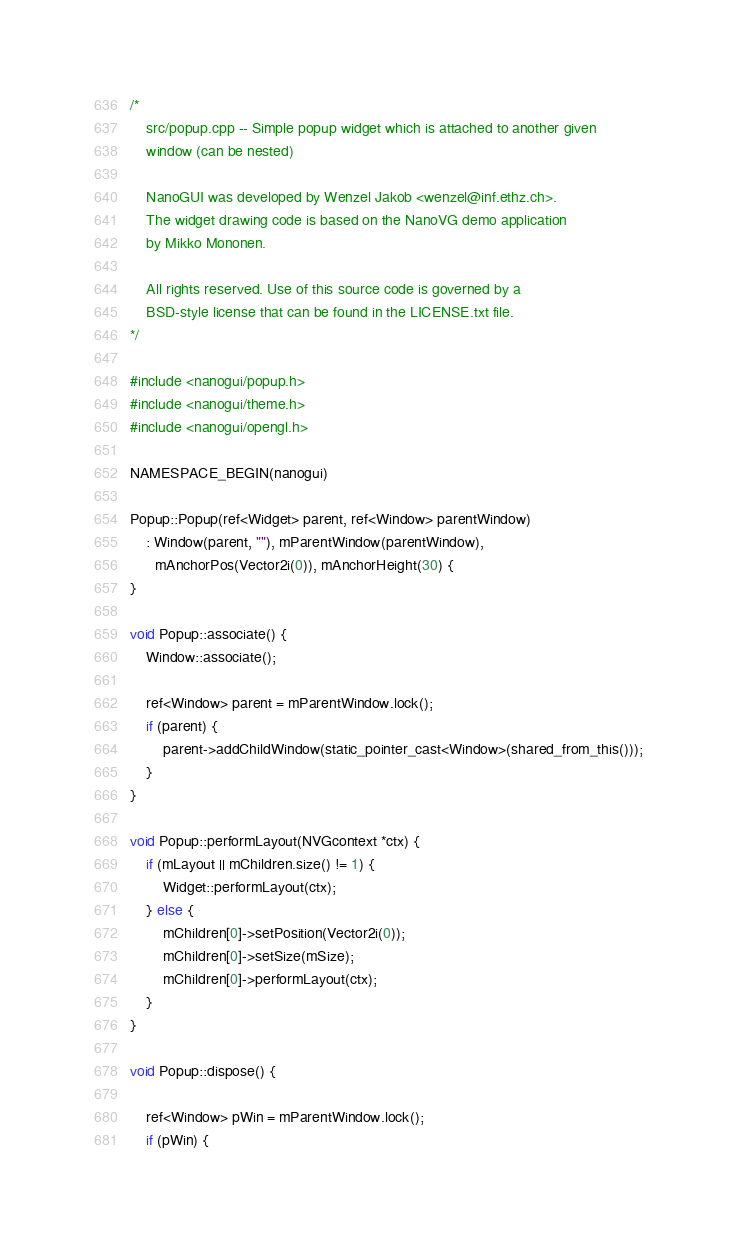Convert code to text. <code><loc_0><loc_0><loc_500><loc_500><_C++_>/*
    src/popup.cpp -- Simple popup widget which is attached to another given
    window (can be nested)

    NanoGUI was developed by Wenzel Jakob <wenzel@inf.ethz.ch>.
    The widget drawing code is based on the NanoVG demo application
    by Mikko Mononen.

    All rights reserved. Use of this source code is governed by a
    BSD-style license that can be found in the LICENSE.txt file.
*/

#include <nanogui/popup.h>
#include <nanogui/theme.h>
#include <nanogui/opengl.h>

NAMESPACE_BEGIN(nanogui)
    
Popup::Popup(ref<Widget> parent, ref<Window> parentWindow)
    : Window(parent, ""), mParentWindow(parentWindow),
      mAnchorPos(Vector2i(0)), mAnchorHeight(30) {
}

void Popup::associate() {
	Window::associate();

	ref<Window> parent = mParentWindow.lock();
	if (parent) {
		parent->addChildWindow(static_pointer_cast<Window>(shared_from_this()));
	}
}

void Popup::performLayout(NVGcontext *ctx) {
    if (mLayout || mChildren.size() != 1) {
        Widget::performLayout(ctx);
    } else {
        mChildren[0]->setPosition(Vector2i(0));
        mChildren[0]->setSize(mSize);
        mChildren[0]->performLayout(ctx);
    }
}

void Popup::dispose() {

	ref<Window> pWin = mParentWindow.lock();
	if (pWin) {</code> 